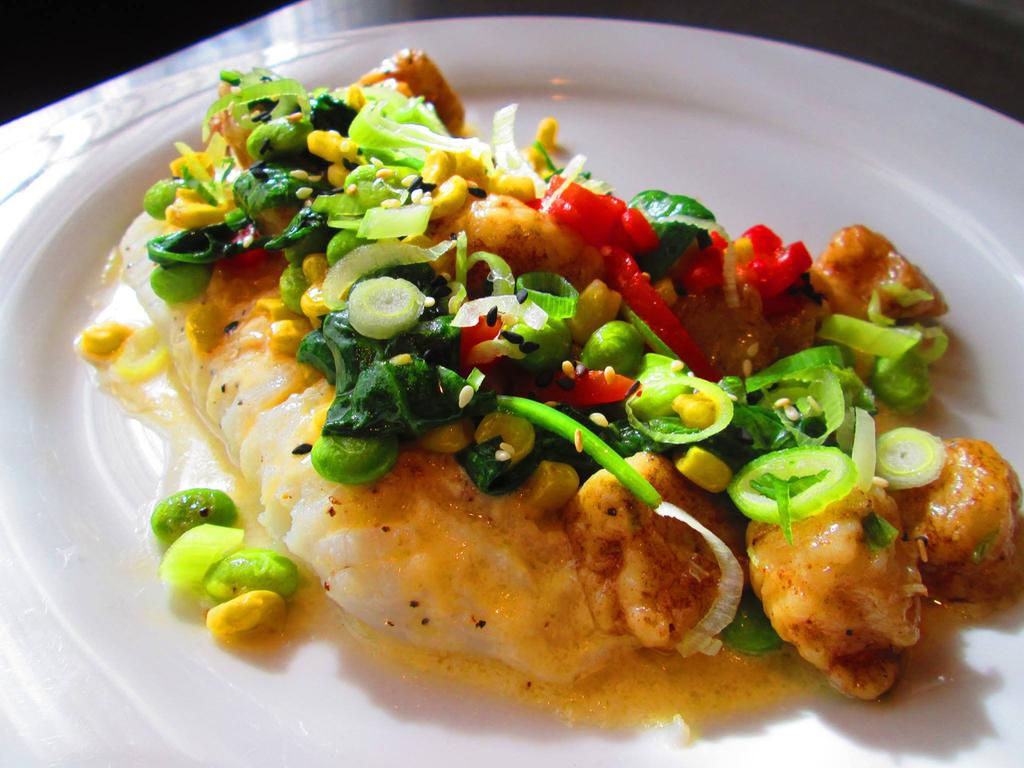What is the main object in the image? There is a dish in the image. How is the dish presented? The dish is served in a plate. What type of suit is the goldfish wearing in the image? There is no goldfish or suit present in the image. 